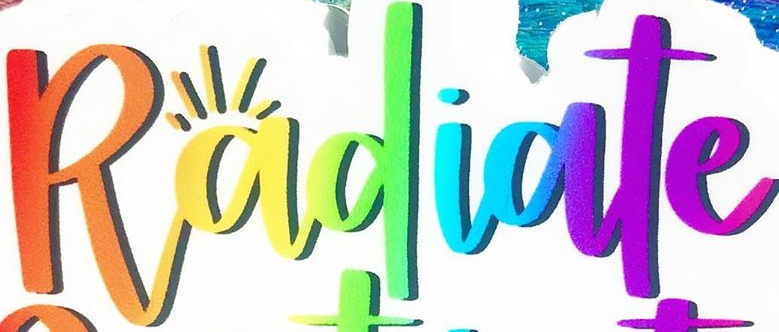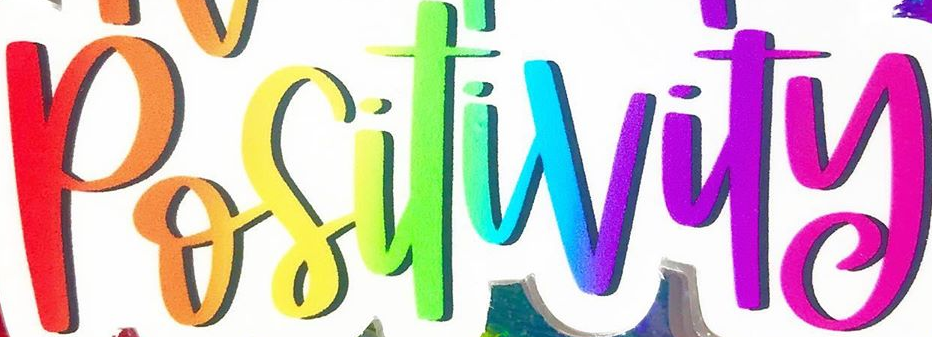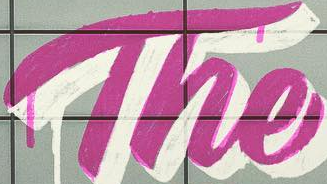Read the text content from these images in order, separated by a semicolon. Radiate; Positivity; The 